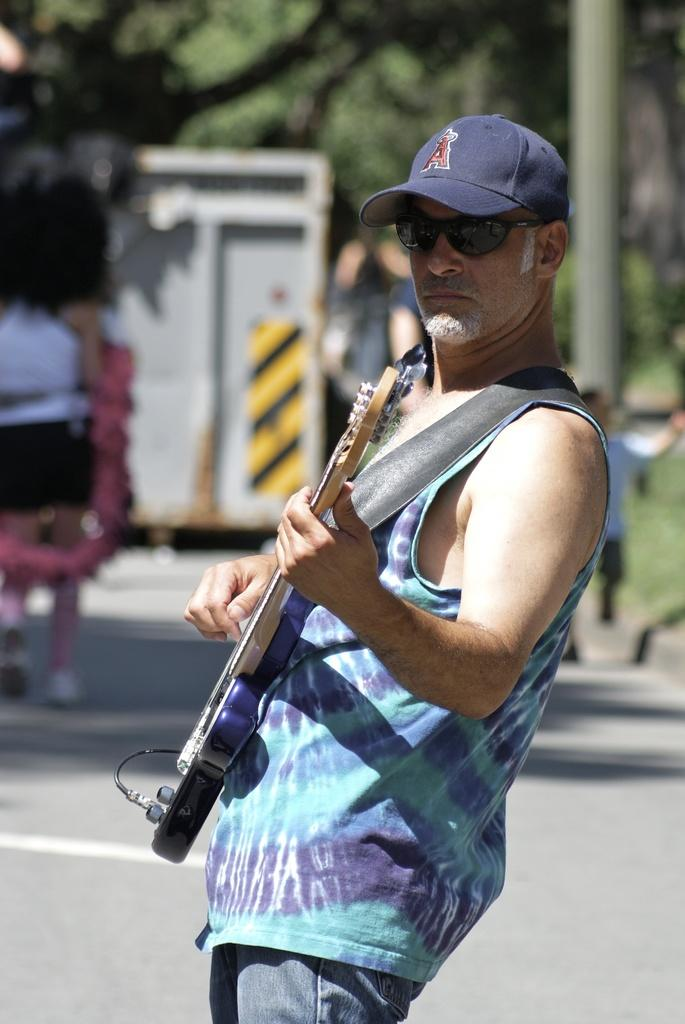What is the main subject of the image? The main subject of the image is a man. What is the man doing in the image? The man is standing and playing the guitar. What is the man wearing in the image? The man is wearing a blue t-shirt and a cap. What can be seen in the background of the image? There is a road in the image. What type of lock can be seen on the prison door in the image? There is no prison or lock present in the image; it features a man playing the guitar. What type of servant is attending to the man in the image? There is no servant present in the image; the man is playing the guitar by himself. 